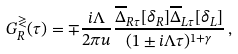Convert formula to latex. <formula><loc_0><loc_0><loc_500><loc_500>G ^ { \gtrless } _ { R } ( \tau ) = \mp \frac { i \Lambda } { 2 \pi u } \frac { \overline { \Delta } _ { R \tau } [ \delta _ { R } ] \overline { \Delta } _ { L \tau } [ \delta _ { L } ] } { ( 1 \pm i \Lambda \tau ) ^ { 1 + \gamma } } \, ,</formula> 